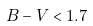Convert formula to latex. <formula><loc_0><loc_0><loc_500><loc_500>B - V < 1 . 7</formula> 